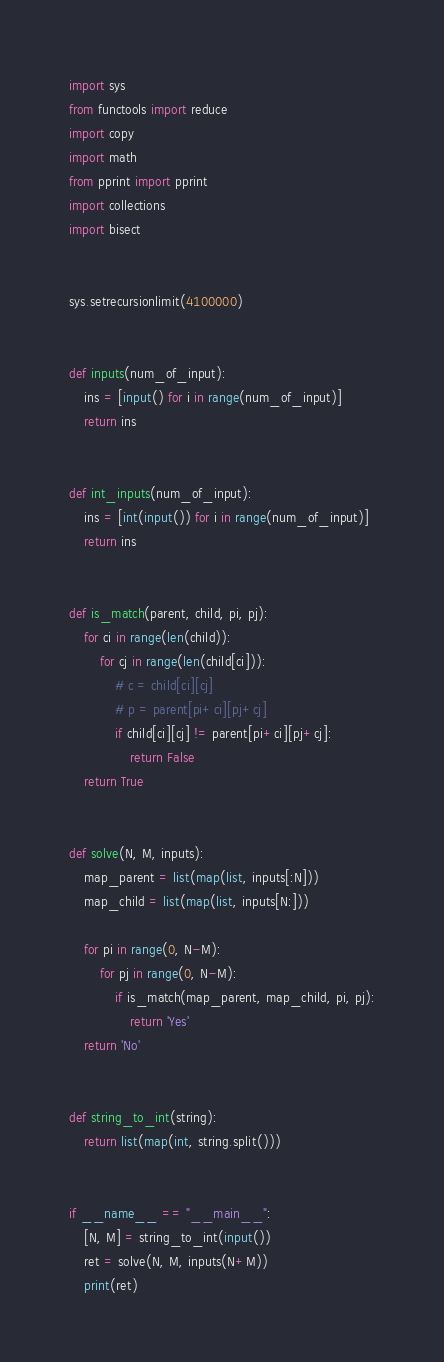<code> <loc_0><loc_0><loc_500><loc_500><_Python_>import sys
from functools import reduce
import copy
import math
from pprint import pprint
import collections
import bisect


sys.setrecursionlimit(4100000)


def inputs(num_of_input):
    ins = [input() for i in range(num_of_input)]
    return ins


def int_inputs(num_of_input):
    ins = [int(input()) for i in range(num_of_input)]
    return ins


def is_match(parent, child, pi, pj):
    for ci in range(len(child)):
        for cj in range(len(child[ci])):
            # c = child[ci][cj]
            # p = parent[pi+ci][pj+cj]
            if child[ci][cj] != parent[pi+ci][pj+cj]:
                return False
    return True


def solve(N, M, inputs):
    map_parent = list(map(list, inputs[:N]))
    map_child = list(map(list, inputs[N:]))

    for pi in range(0, N-M):
        for pj in range(0, N-M):
            if is_match(map_parent, map_child, pi, pj):
                return 'Yes'
    return 'No'


def string_to_int(string):
    return list(map(int, string.split()))


if __name__ == "__main__":
    [N, M] = string_to_int(input())
    ret = solve(N, M, inputs(N+M))
    print(ret)
</code> 